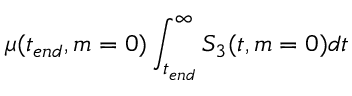Convert formula to latex. <formula><loc_0><loc_0><loc_500><loc_500>\mu ( t _ { e n d } , m = 0 ) \int _ { t _ { e n d } } ^ { \infty } S _ { 3 } ( t , m = 0 ) d t</formula> 